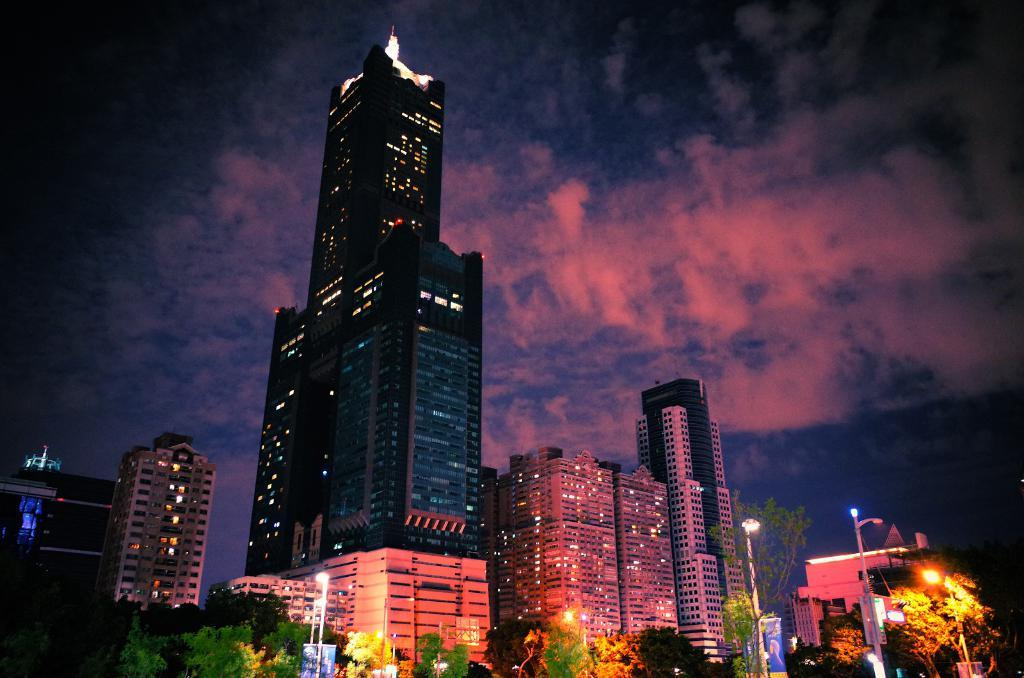What type of structures are present in the image? There are buildings and skyscrapers in the image. What can be seen at the bottom of the image? There are trees and street light poles at the bottom of the image. What is visible at the top of the image? The sky is visible at the top of the image. How many passengers are visible in the image? There are no passengers present in the image. What type of paper is being used to create the buildings in the image? The image is not created using paper, so there is no paper involved in the construction of the buildings. 